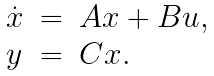<formula> <loc_0><loc_0><loc_500><loc_500>\begin{array} { l l l } \dot { x } & = & A x + B u , \\ y & = & C x . \end{array}</formula> 